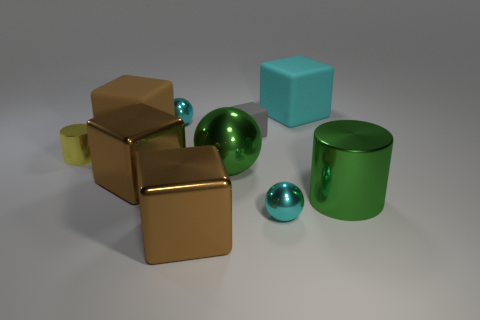How many brown blocks must be subtracted to get 1 brown blocks? 2 Subtract all brown cylinders. How many brown cubes are left? 3 Subtract 1 blocks. How many blocks are left? 4 Subtract all green blocks. Subtract all yellow cylinders. How many blocks are left? 5 Subtract all balls. How many objects are left? 7 Subtract 0 purple cubes. How many objects are left? 10 Subtract all blue shiny blocks. Subtract all large green metal cylinders. How many objects are left? 9 Add 5 green things. How many green things are left? 7 Add 3 big cyan objects. How many big cyan objects exist? 4 